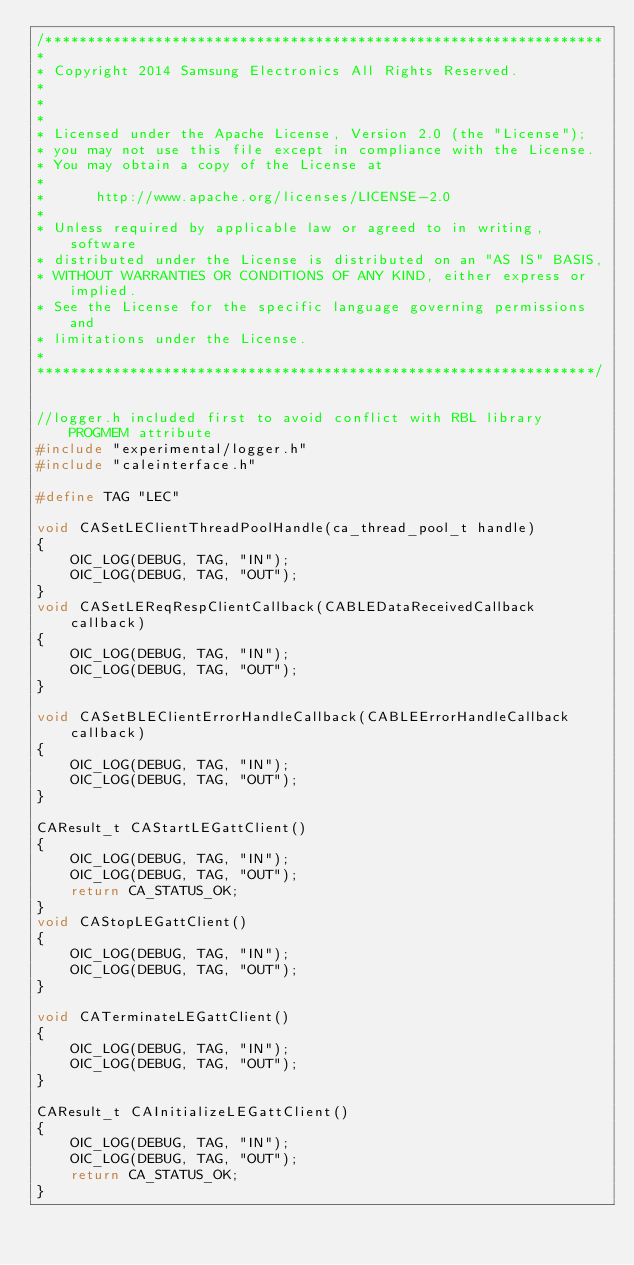Convert code to text. <code><loc_0><loc_0><loc_500><loc_500><_C++_>/******************************************************************
*
* Copyright 2014 Samsung Electronics All Rights Reserved.
*
*
*
* Licensed under the Apache License, Version 2.0 (the "License");
* you may not use this file except in compliance with the License.
* You may obtain a copy of the License at
*
*      http://www.apache.org/licenses/LICENSE-2.0
*
* Unless required by applicable law or agreed to in writing, software
* distributed under the License is distributed on an "AS IS" BASIS,
* WITHOUT WARRANTIES OR CONDITIONS OF ANY KIND, either express or implied.
* See the License for the specific language governing permissions and
* limitations under the License.
*
******************************************************************/


//logger.h included first to avoid conflict with RBL library PROGMEM attribute
#include "experimental/logger.h"
#include "caleinterface.h"

#define TAG "LEC"

void CASetLEClientThreadPoolHandle(ca_thread_pool_t handle)
{
    OIC_LOG(DEBUG, TAG, "IN");
    OIC_LOG(DEBUG, TAG, "OUT");
}
void CASetLEReqRespClientCallback(CABLEDataReceivedCallback callback)
{
    OIC_LOG(DEBUG, TAG, "IN");
    OIC_LOG(DEBUG, TAG, "OUT");
}

void CASetBLEClientErrorHandleCallback(CABLEErrorHandleCallback callback)
{
    OIC_LOG(DEBUG, TAG, "IN");
    OIC_LOG(DEBUG, TAG, "OUT");
}

CAResult_t CAStartLEGattClient()
{
    OIC_LOG(DEBUG, TAG, "IN");
    OIC_LOG(DEBUG, TAG, "OUT");
    return CA_STATUS_OK;
}
void CAStopLEGattClient()
{
    OIC_LOG(DEBUG, TAG, "IN");
    OIC_LOG(DEBUG, TAG, "OUT");
}

void CATerminateLEGattClient()
{
    OIC_LOG(DEBUG, TAG, "IN");
    OIC_LOG(DEBUG, TAG, "OUT");
}

CAResult_t CAInitializeLEGattClient()
{
    OIC_LOG(DEBUG, TAG, "IN");
    OIC_LOG(DEBUG, TAG, "OUT");
    return CA_STATUS_OK;
}
</code> 